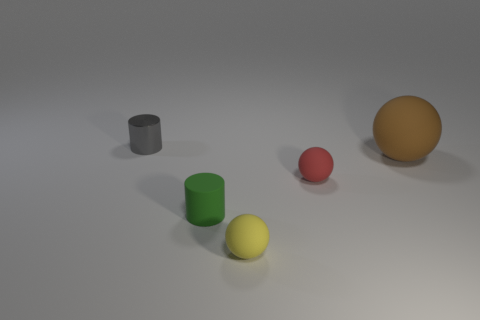What can be inferred about the surface on which the objects are resting? The objects are resting on what appears to be an even, matte surface that softly reflects some light, hinting at a non-glossy texture. The surface's light color adds to the scene's overall muted palette. 